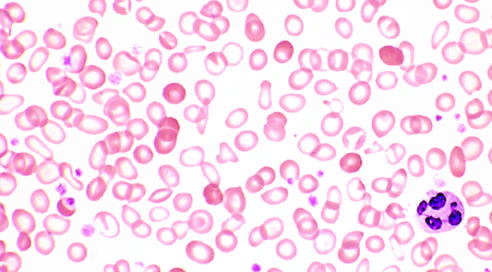what stands out in contrast?
Answer the question using a single word or phrase. Scattered 